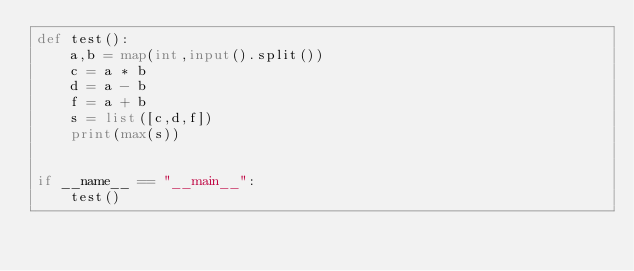Convert code to text. <code><loc_0><loc_0><loc_500><loc_500><_Python_>def test():
    a,b = map(int,input().split())
    c = a * b
    d = a - b
    f = a + b
    s = list([c,d,f])
    print(max(s))


if __name__ == "__main__":
    test()
</code> 